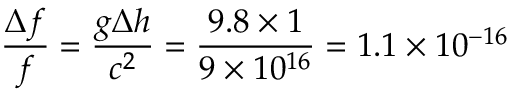<formula> <loc_0><loc_0><loc_500><loc_500>\frac { \Delta f } { f } = \frac { g \Delta h } { c ^ { 2 } } = \frac { 9 . 8 \times 1 } { 9 \times 1 0 ^ { 1 6 } } = 1 . 1 \times 1 0 ^ { - 1 6 }</formula> 